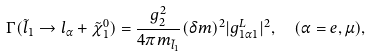<formula> <loc_0><loc_0><loc_500><loc_500>\Gamma ( \tilde { l } _ { 1 } \to l _ { \alpha } + \tilde { \chi } _ { 1 } ^ { 0 } ) & = \frac { g ^ { 2 } _ { 2 } } { 4 \pi m _ { \tilde { l } _ { 1 } } } ( \delta m ) ^ { 2 } | g _ { 1 \alpha 1 } ^ { L } | ^ { 2 } , \quad ( \alpha = e , \mu ) ,</formula> 